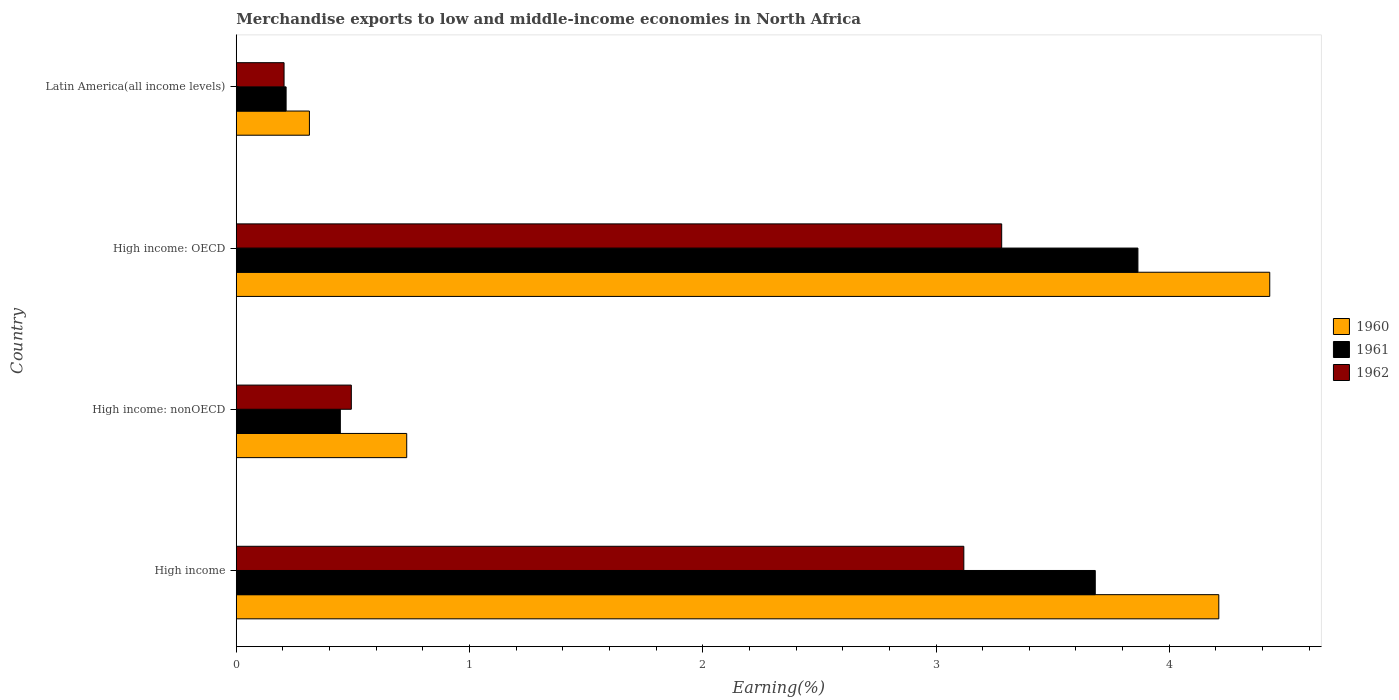Are the number of bars per tick equal to the number of legend labels?
Give a very brief answer. Yes. How many bars are there on the 2nd tick from the top?
Provide a succinct answer. 3. What is the label of the 4th group of bars from the top?
Your answer should be very brief. High income. In how many cases, is the number of bars for a given country not equal to the number of legend labels?
Your answer should be compact. 0. What is the percentage of amount earned from merchandise exports in 1962 in High income: OECD?
Provide a succinct answer. 3.28. Across all countries, what is the maximum percentage of amount earned from merchandise exports in 1962?
Ensure brevity in your answer.  3.28. Across all countries, what is the minimum percentage of amount earned from merchandise exports in 1962?
Provide a succinct answer. 0.2. In which country was the percentage of amount earned from merchandise exports in 1962 maximum?
Provide a short and direct response. High income: OECD. In which country was the percentage of amount earned from merchandise exports in 1962 minimum?
Provide a short and direct response. Latin America(all income levels). What is the total percentage of amount earned from merchandise exports in 1961 in the graph?
Keep it short and to the point. 8.21. What is the difference between the percentage of amount earned from merchandise exports in 1961 in High income and that in Latin America(all income levels)?
Your answer should be very brief. 3.47. What is the difference between the percentage of amount earned from merchandise exports in 1960 in High income: OECD and the percentage of amount earned from merchandise exports in 1962 in Latin America(all income levels)?
Give a very brief answer. 4.23. What is the average percentage of amount earned from merchandise exports in 1960 per country?
Offer a terse response. 2.42. What is the difference between the percentage of amount earned from merchandise exports in 1961 and percentage of amount earned from merchandise exports in 1962 in Latin America(all income levels)?
Offer a terse response. 0.01. What is the ratio of the percentage of amount earned from merchandise exports in 1961 in High income to that in High income: OECD?
Offer a terse response. 0.95. Is the difference between the percentage of amount earned from merchandise exports in 1961 in High income and High income: nonOECD greater than the difference between the percentage of amount earned from merchandise exports in 1962 in High income and High income: nonOECD?
Ensure brevity in your answer.  Yes. What is the difference between the highest and the second highest percentage of amount earned from merchandise exports in 1961?
Offer a very short reply. 0.18. What is the difference between the highest and the lowest percentage of amount earned from merchandise exports in 1961?
Provide a short and direct response. 3.65. In how many countries, is the percentage of amount earned from merchandise exports in 1960 greater than the average percentage of amount earned from merchandise exports in 1960 taken over all countries?
Your answer should be compact. 2. Is the sum of the percentage of amount earned from merchandise exports in 1960 in High income: OECD and Latin America(all income levels) greater than the maximum percentage of amount earned from merchandise exports in 1961 across all countries?
Your response must be concise. Yes. What does the 1st bar from the top in Latin America(all income levels) represents?
Keep it short and to the point. 1962. Is it the case that in every country, the sum of the percentage of amount earned from merchandise exports in 1960 and percentage of amount earned from merchandise exports in 1962 is greater than the percentage of amount earned from merchandise exports in 1961?
Provide a short and direct response. Yes. How many bars are there?
Make the answer very short. 12. Does the graph contain grids?
Your answer should be very brief. No. How are the legend labels stacked?
Provide a short and direct response. Vertical. What is the title of the graph?
Keep it short and to the point. Merchandise exports to low and middle-income economies in North Africa. What is the label or title of the X-axis?
Offer a very short reply. Earning(%). What is the Earning(%) in 1960 in High income?
Your answer should be very brief. 4.21. What is the Earning(%) in 1961 in High income?
Give a very brief answer. 3.68. What is the Earning(%) in 1962 in High income?
Give a very brief answer. 3.12. What is the Earning(%) in 1960 in High income: nonOECD?
Ensure brevity in your answer.  0.73. What is the Earning(%) in 1961 in High income: nonOECD?
Your answer should be very brief. 0.45. What is the Earning(%) of 1962 in High income: nonOECD?
Offer a terse response. 0.49. What is the Earning(%) in 1960 in High income: OECD?
Offer a very short reply. 4.43. What is the Earning(%) in 1961 in High income: OECD?
Your answer should be very brief. 3.87. What is the Earning(%) in 1962 in High income: OECD?
Your response must be concise. 3.28. What is the Earning(%) of 1960 in Latin America(all income levels)?
Your answer should be compact. 0.31. What is the Earning(%) of 1961 in Latin America(all income levels)?
Provide a short and direct response. 0.21. What is the Earning(%) in 1962 in Latin America(all income levels)?
Ensure brevity in your answer.  0.2. Across all countries, what is the maximum Earning(%) in 1960?
Ensure brevity in your answer.  4.43. Across all countries, what is the maximum Earning(%) in 1961?
Provide a succinct answer. 3.87. Across all countries, what is the maximum Earning(%) in 1962?
Give a very brief answer. 3.28. Across all countries, what is the minimum Earning(%) in 1960?
Ensure brevity in your answer.  0.31. Across all countries, what is the minimum Earning(%) in 1961?
Provide a short and direct response. 0.21. Across all countries, what is the minimum Earning(%) in 1962?
Make the answer very short. 0.2. What is the total Earning(%) of 1960 in the graph?
Make the answer very short. 9.69. What is the total Earning(%) of 1961 in the graph?
Make the answer very short. 8.21. What is the total Earning(%) of 1962 in the graph?
Your answer should be very brief. 7.1. What is the difference between the Earning(%) of 1960 in High income and that in High income: nonOECD?
Keep it short and to the point. 3.48. What is the difference between the Earning(%) of 1961 in High income and that in High income: nonOECD?
Make the answer very short. 3.24. What is the difference between the Earning(%) in 1962 in High income and that in High income: nonOECD?
Your answer should be very brief. 2.63. What is the difference between the Earning(%) in 1960 in High income and that in High income: OECD?
Offer a terse response. -0.22. What is the difference between the Earning(%) in 1961 in High income and that in High income: OECD?
Your answer should be compact. -0.18. What is the difference between the Earning(%) in 1962 in High income and that in High income: OECD?
Offer a very short reply. -0.16. What is the difference between the Earning(%) in 1960 in High income and that in Latin America(all income levels)?
Offer a very short reply. 3.9. What is the difference between the Earning(%) of 1961 in High income and that in Latin America(all income levels)?
Give a very brief answer. 3.47. What is the difference between the Earning(%) of 1962 in High income and that in Latin America(all income levels)?
Offer a terse response. 2.91. What is the difference between the Earning(%) of 1960 in High income: nonOECD and that in High income: OECD?
Your answer should be very brief. -3.7. What is the difference between the Earning(%) of 1961 in High income: nonOECD and that in High income: OECD?
Your response must be concise. -3.42. What is the difference between the Earning(%) in 1962 in High income: nonOECD and that in High income: OECD?
Offer a terse response. -2.79. What is the difference between the Earning(%) in 1960 in High income: nonOECD and that in Latin America(all income levels)?
Offer a terse response. 0.42. What is the difference between the Earning(%) in 1961 in High income: nonOECD and that in Latin America(all income levels)?
Make the answer very short. 0.23. What is the difference between the Earning(%) in 1962 in High income: nonOECD and that in Latin America(all income levels)?
Give a very brief answer. 0.29. What is the difference between the Earning(%) of 1960 in High income: OECD and that in Latin America(all income levels)?
Provide a succinct answer. 4.12. What is the difference between the Earning(%) in 1961 in High income: OECD and that in Latin America(all income levels)?
Give a very brief answer. 3.65. What is the difference between the Earning(%) in 1962 in High income: OECD and that in Latin America(all income levels)?
Give a very brief answer. 3.08. What is the difference between the Earning(%) of 1960 in High income and the Earning(%) of 1961 in High income: nonOECD?
Your response must be concise. 3.77. What is the difference between the Earning(%) of 1960 in High income and the Earning(%) of 1962 in High income: nonOECD?
Offer a very short reply. 3.72. What is the difference between the Earning(%) in 1961 in High income and the Earning(%) in 1962 in High income: nonOECD?
Ensure brevity in your answer.  3.19. What is the difference between the Earning(%) of 1960 in High income and the Earning(%) of 1961 in High income: OECD?
Make the answer very short. 0.35. What is the difference between the Earning(%) of 1960 in High income and the Earning(%) of 1962 in High income: OECD?
Ensure brevity in your answer.  0.93. What is the difference between the Earning(%) in 1961 in High income and the Earning(%) in 1962 in High income: OECD?
Offer a very short reply. 0.4. What is the difference between the Earning(%) of 1960 in High income and the Earning(%) of 1961 in Latin America(all income levels)?
Your answer should be compact. 4. What is the difference between the Earning(%) in 1960 in High income and the Earning(%) in 1962 in Latin America(all income levels)?
Your response must be concise. 4.01. What is the difference between the Earning(%) of 1961 in High income and the Earning(%) of 1962 in Latin America(all income levels)?
Offer a very short reply. 3.48. What is the difference between the Earning(%) of 1960 in High income: nonOECD and the Earning(%) of 1961 in High income: OECD?
Offer a very short reply. -3.13. What is the difference between the Earning(%) in 1960 in High income: nonOECD and the Earning(%) in 1962 in High income: OECD?
Give a very brief answer. -2.55. What is the difference between the Earning(%) of 1961 in High income: nonOECD and the Earning(%) of 1962 in High income: OECD?
Ensure brevity in your answer.  -2.84. What is the difference between the Earning(%) of 1960 in High income: nonOECD and the Earning(%) of 1961 in Latin America(all income levels)?
Give a very brief answer. 0.52. What is the difference between the Earning(%) in 1960 in High income: nonOECD and the Earning(%) in 1962 in Latin America(all income levels)?
Your answer should be compact. 0.53. What is the difference between the Earning(%) in 1961 in High income: nonOECD and the Earning(%) in 1962 in Latin America(all income levels)?
Your answer should be very brief. 0.24. What is the difference between the Earning(%) in 1960 in High income: OECD and the Earning(%) in 1961 in Latin America(all income levels)?
Keep it short and to the point. 4.22. What is the difference between the Earning(%) of 1960 in High income: OECD and the Earning(%) of 1962 in Latin America(all income levels)?
Offer a terse response. 4.23. What is the difference between the Earning(%) in 1961 in High income: OECD and the Earning(%) in 1962 in Latin America(all income levels)?
Your answer should be compact. 3.66. What is the average Earning(%) of 1960 per country?
Provide a short and direct response. 2.42. What is the average Earning(%) of 1961 per country?
Offer a very short reply. 2.05. What is the average Earning(%) of 1962 per country?
Provide a short and direct response. 1.77. What is the difference between the Earning(%) of 1960 and Earning(%) of 1961 in High income?
Your response must be concise. 0.53. What is the difference between the Earning(%) in 1960 and Earning(%) in 1962 in High income?
Give a very brief answer. 1.09. What is the difference between the Earning(%) of 1961 and Earning(%) of 1962 in High income?
Keep it short and to the point. 0.56. What is the difference between the Earning(%) of 1960 and Earning(%) of 1961 in High income: nonOECD?
Ensure brevity in your answer.  0.28. What is the difference between the Earning(%) in 1960 and Earning(%) in 1962 in High income: nonOECD?
Ensure brevity in your answer.  0.24. What is the difference between the Earning(%) of 1961 and Earning(%) of 1962 in High income: nonOECD?
Provide a succinct answer. -0.05. What is the difference between the Earning(%) in 1960 and Earning(%) in 1961 in High income: OECD?
Offer a terse response. 0.57. What is the difference between the Earning(%) in 1960 and Earning(%) in 1962 in High income: OECD?
Give a very brief answer. 1.15. What is the difference between the Earning(%) of 1961 and Earning(%) of 1962 in High income: OECD?
Provide a succinct answer. 0.58. What is the difference between the Earning(%) in 1960 and Earning(%) in 1961 in Latin America(all income levels)?
Offer a terse response. 0.1. What is the difference between the Earning(%) in 1960 and Earning(%) in 1962 in Latin America(all income levels)?
Your answer should be very brief. 0.11. What is the difference between the Earning(%) in 1961 and Earning(%) in 1962 in Latin America(all income levels)?
Offer a terse response. 0.01. What is the ratio of the Earning(%) in 1960 in High income to that in High income: nonOECD?
Make the answer very short. 5.76. What is the ratio of the Earning(%) in 1961 in High income to that in High income: nonOECD?
Make the answer very short. 8.25. What is the ratio of the Earning(%) in 1962 in High income to that in High income: nonOECD?
Provide a succinct answer. 6.32. What is the ratio of the Earning(%) of 1960 in High income to that in High income: OECD?
Give a very brief answer. 0.95. What is the ratio of the Earning(%) of 1961 in High income to that in High income: OECD?
Your response must be concise. 0.95. What is the ratio of the Earning(%) of 1962 in High income to that in High income: OECD?
Offer a terse response. 0.95. What is the ratio of the Earning(%) of 1960 in High income to that in Latin America(all income levels)?
Your answer should be compact. 13.43. What is the ratio of the Earning(%) of 1961 in High income to that in Latin America(all income levels)?
Your response must be concise. 17.23. What is the ratio of the Earning(%) of 1962 in High income to that in Latin America(all income levels)?
Ensure brevity in your answer.  15.22. What is the ratio of the Earning(%) of 1960 in High income: nonOECD to that in High income: OECD?
Ensure brevity in your answer.  0.16. What is the ratio of the Earning(%) of 1961 in High income: nonOECD to that in High income: OECD?
Offer a very short reply. 0.12. What is the ratio of the Earning(%) of 1962 in High income: nonOECD to that in High income: OECD?
Provide a short and direct response. 0.15. What is the ratio of the Earning(%) in 1960 in High income: nonOECD to that in Latin America(all income levels)?
Provide a short and direct response. 2.33. What is the ratio of the Earning(%) of 1961 in High income: nonOECD to that in Latin America(all income levels)?
Offer a very short reply. 2.09. What is the ratio of the Earning(%) in 1962 in High income: nonOECD to that in Latin America(all income levels)?
Provide a short and direct response. 2.41. What is the ratio of the Earning(%) in 1960 in High income: OECD to that in Latin America(all income levels)?
Ensure brevity in your answer.  14.12. What is the ratio of the Earning(%) of 1961 in High income: OECD to that in Latin America(all income levels)?
Your answer should be very brief. 18.08. What is the ratio of the Earning(%) in 1962 in High income: OECD to that in Latin America(all income levels)?
Offer a terse response. 16.01. What is the difference between the highest and the second highest Earning(%) of 1960?
Keep it short and to the point. 0.22. What is the difference between the highest and the second highest Earning(%) in 1961?
Provide a short and direct response. 0.18. What is the difference between the highest and the second highest Earning(%) in 1962?
Offer a very short reply. 0.16. What is the difference between the highest and the lowest Earning(%) in 1960?
Offer a very short reply. 4.12. What is the difference between the highest and the lowest Earning(%) of 1961?
Provide a succinct answer. 3.65. What is the difference between the highest and the lowest Earning(%) of 1962?
Keep it short and to the point. 3.08. 